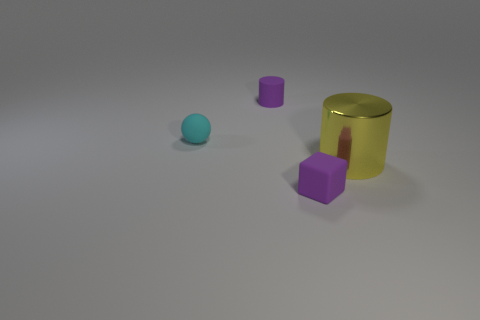Are there any other things that are the same size as the yellow thing?
Ensure brevity in your answer.  No. Is there any other thing that is made of the same material as the yellow object?
Make the answer very short. No. What is the color of the other thing that is the same shape as the big shiny thing?
Make the answer very short. Purple. There is a purple thing behind the small ball; are there any balls that are on the right side of it?
Provide a short and direct response. No. The purple matte cylinder has what size?
Provide a succinct answer. Small. There is a thing that is in front of the cyan object and to the left of the large yellow metal object; what shape is it?
Ensure brevity in your answer.  Cube. How many red things are big metallic cylinders or matte blocks?
Provide a succinct answer. 0. There is a purple matte thing in front of the ball; does it have the same size as the purple rubber object that is on the left side of the tiny rubber cube?
Your answer should be very brief. Yes. How many things are either small cyan rubber objects or tiny gray matte cubes?
Your response must be concise. 1. Is there a small yellow matte object that has the same shape as the large yellow object?
Make the answer very short. No. 